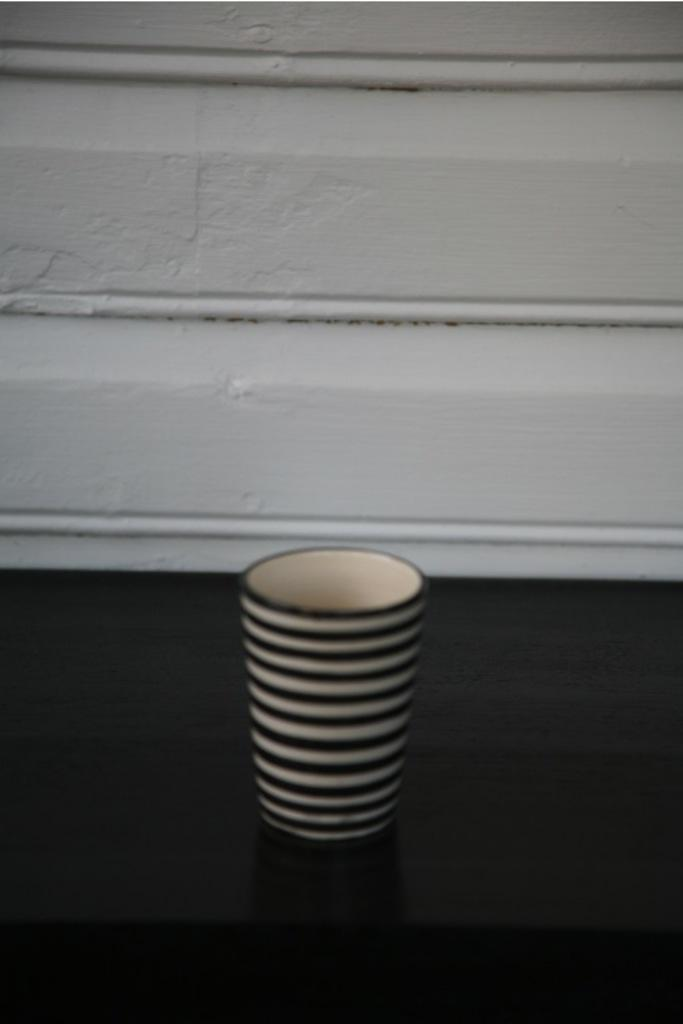What object is present in the image? There is a cup in the image. What colors are used for the cup? The cup is black and white in color. What is the surface beneath the cup? The cup is on a black surface. What can be seen in the background of the image? There is a white wall in the background of the image. How many wishes can be granted by the cup in the image? There are no wishes associated with the cup in the image, as it is an inanimate object. 